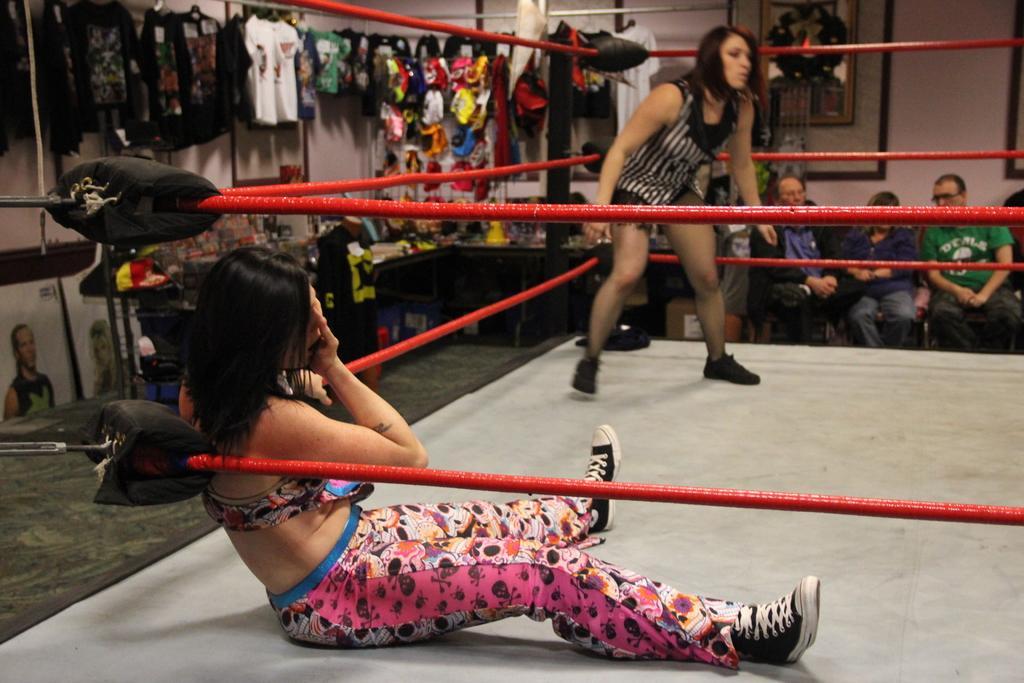Can you describe this image briefly? In this image there are two people in a boxing ring. Behind them there are clothes and a few other objects on the hangers. There are some objects on the table. There are people sitting on the chairs. There are photo frames on the wall. 